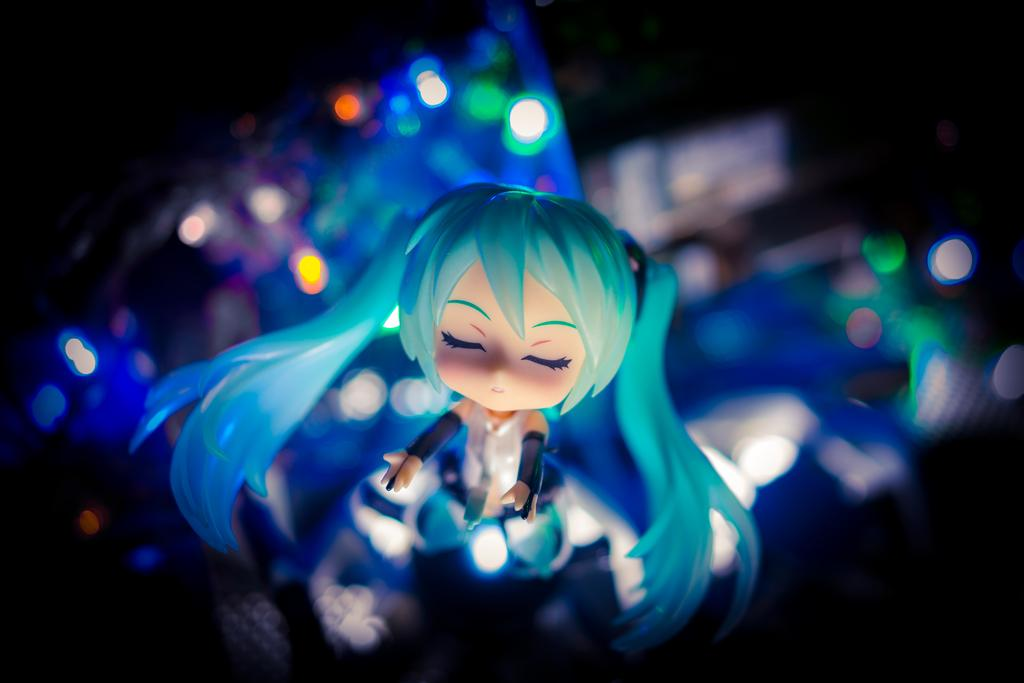What is the main subject in the foreground of the image? There is a toy in the foreground of the image. Can you describe the background of the image? The background of the image is not clear. What type of game is being played in the background of the image? There is no game present in the image, as the background is not clear. Can you describe the journey depicted in the image? There is no journey depicted in the image, as the main subject is a toy in the foreground and the background is not clear. 